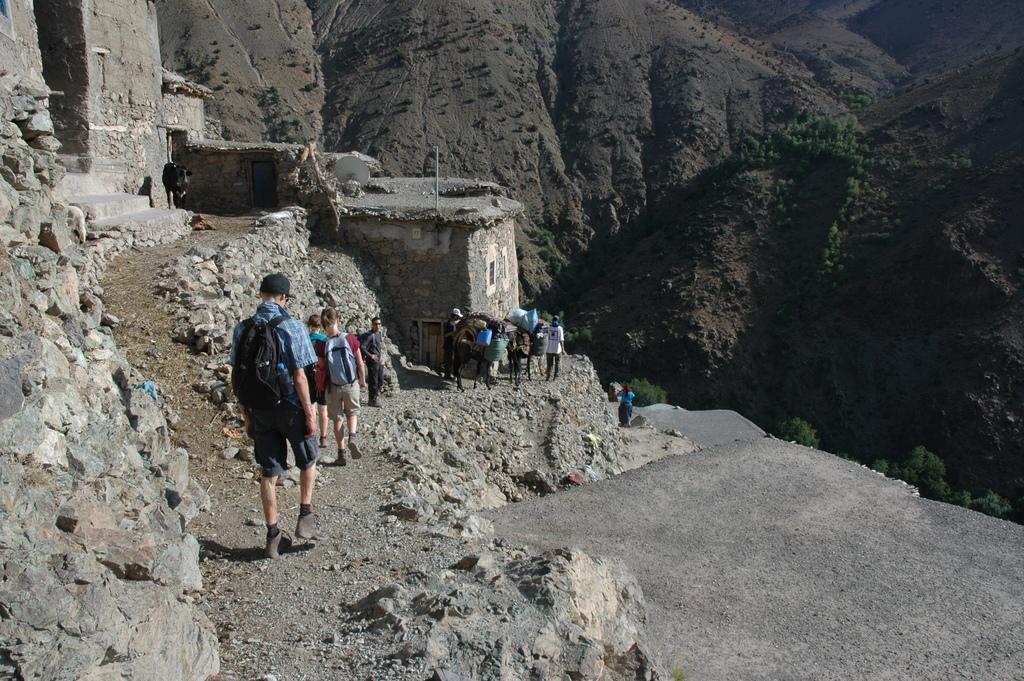Could you give a brief overview of what you see in this image? In this image I can see group of people walking. In front the person is wearing blue shirt, black shirt and black color bag. Background I can see few mountains and trees in green color. 